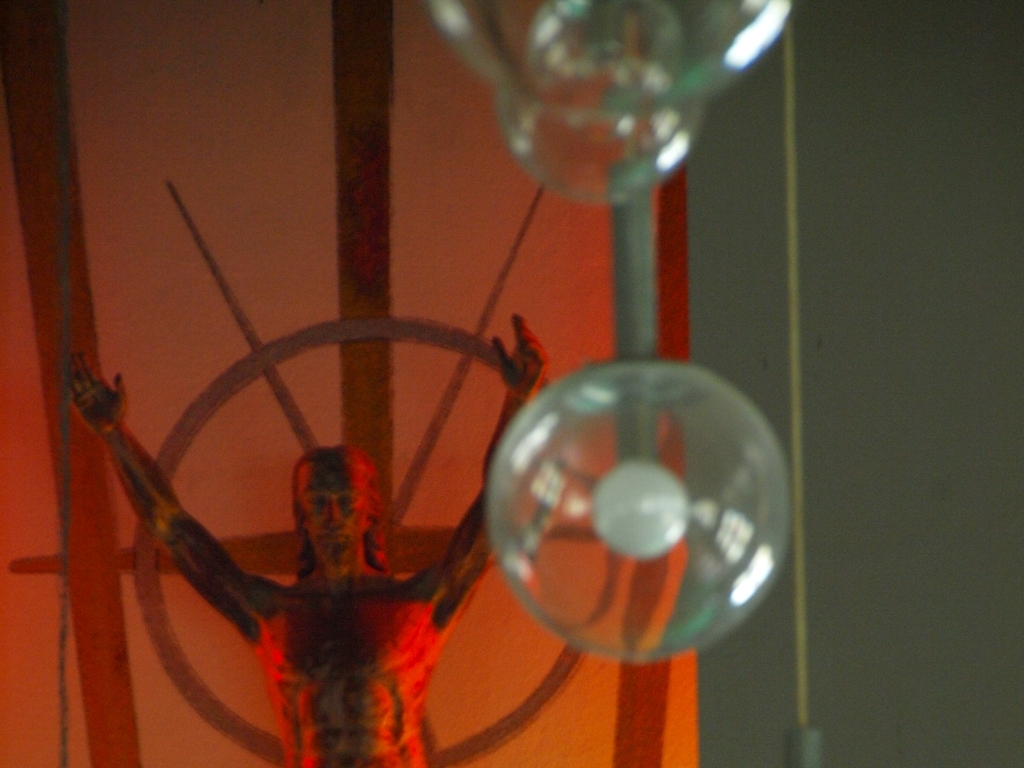What is the sculpture's possible symbolism? The sculpture's pose and design, which include outstretched arms and a wheel-like halo, may draw from religious iconography, potentially alluding to themes of martyrdom or transcendence. The raw treatment of the figure and the intense red coloration could reflect on suffering or a passionate state of being. Could the lighting in the photograph affect the interpretation of the sculpture? Yes, the lighting plays a crucial role in how we perceive the sculpture. The dramatic shadows and the focused illumination contribute to the intensity and emotional impact of the piece, potentially enhancing its intended symbolism and emotional depth. 